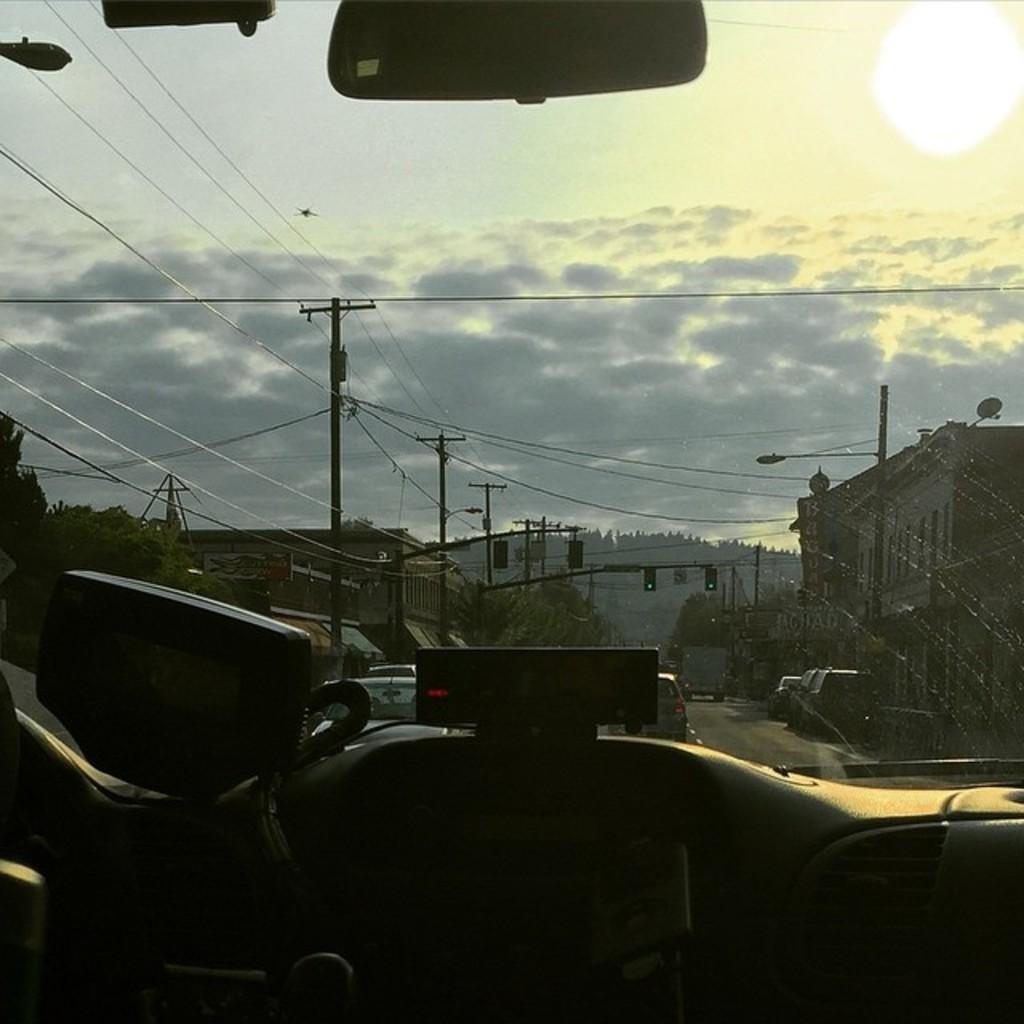How would you summarize this image in a sentence or two? This image is clicked from inside a vehicle through the glass. Outside the class there are vehicles moving on the road. In the background there are buildings, trees and mountains. Beside the road there are electric poles, traffic signal poles and street light poles. 